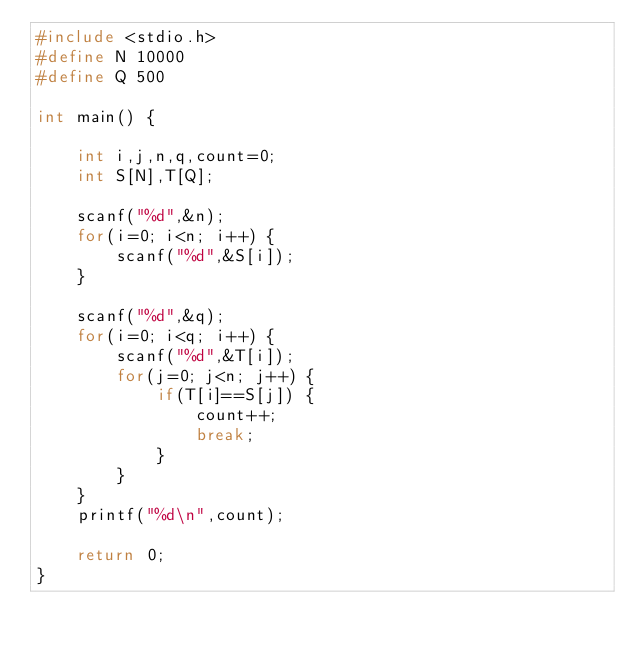<code> <loc_0><loc_0><loc_500><loc_500><_C_>#include <stdio.h>
#define N 10000
#define Q 500

int main() {
    
    int i,j,n,q,count=0;
    int S[N],T[Q];
    
    scanf("%d",&n);
    for(i=0; i<n; i++) {
        scanf("%d",&S[i]);
    }
    
    scanf("%d",&q);
    for(i=0; i<q; i++) {
        scanf("%d",&T[i]);
        for(j=0; j<n; j++) {
            if(T[i]==S[j]) {
                count++;
                break;
            }
        }
    }
    printf("%d\n",count);
    
    return 0;
}</code> 